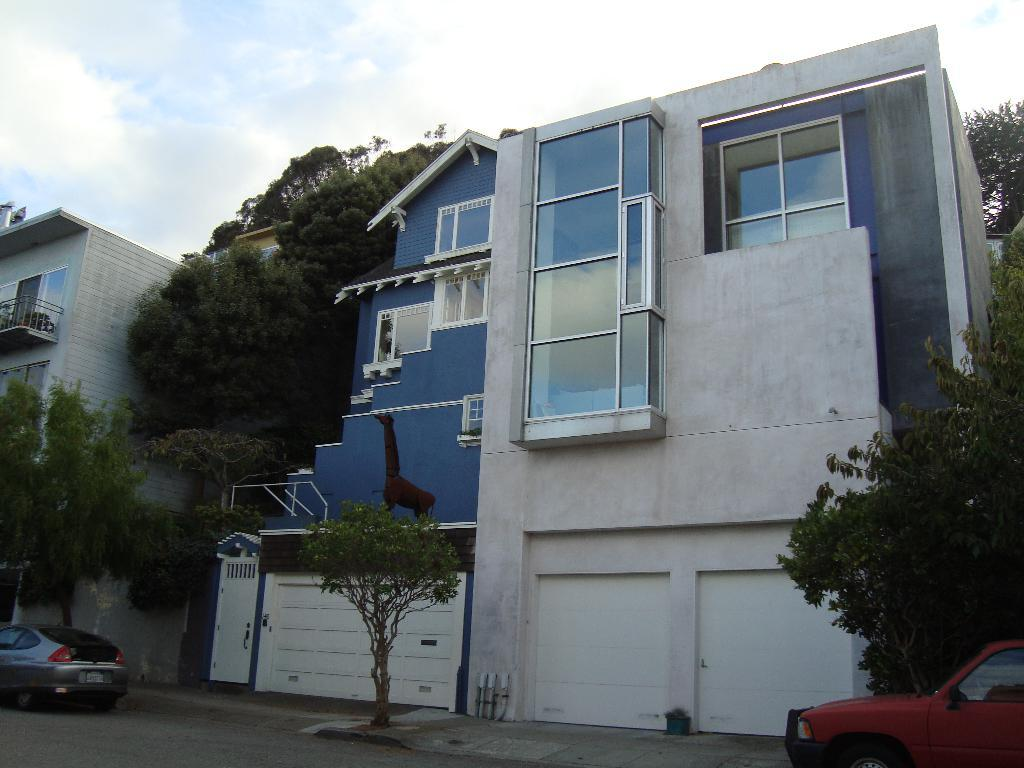What can be seen on the road in the image? There are cars on the road in the image. What is located next to the road in the image? There is a footpath in the image. What type of vegetation is present in the image? There are trees in the image. What type of structures can be seen in the image? There are buildings with windows in the image. What is in the pot in the image? There is a plant in the pot in the image. What is a feature of the building in the image? There is a door in the image. What type of artwork is present in the image? There is a statue in the image. What is visible in the background of the image? The sky with clouds is visible in the background of the image. How many parents are visible in the image? There are no parents present in the image. What type of friction can be seen between the cars in the image? There is no indication of friction between the cars in the image. Are there any cattle visible in the image? There are no cattle present in the image. 